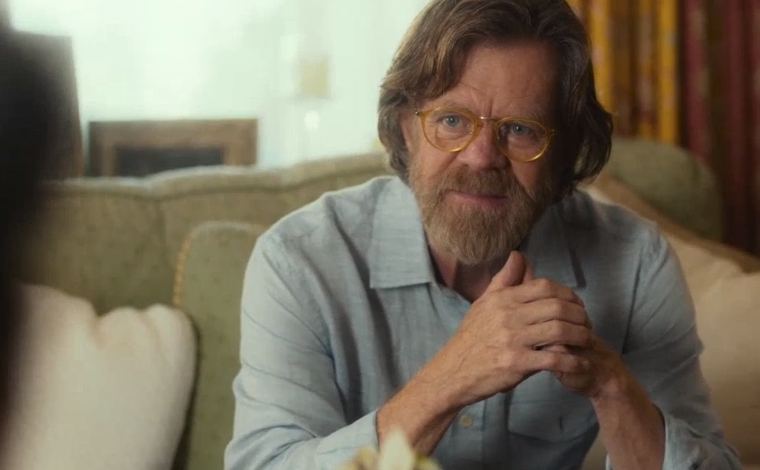What might the man be thinking about in this scene? Given his contemplative expression and the way he clasps his hands, he might be pondering a personal decision or reflecting on a past event, perhaps reminiscing about an important moment in his life or carefully considering what to say next in a conversation. 